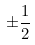Convert formula to latex. <formula><loc_0><loc_0><loc_500><loc_500>\pm \frac { 1 } { 2 }</formula> 